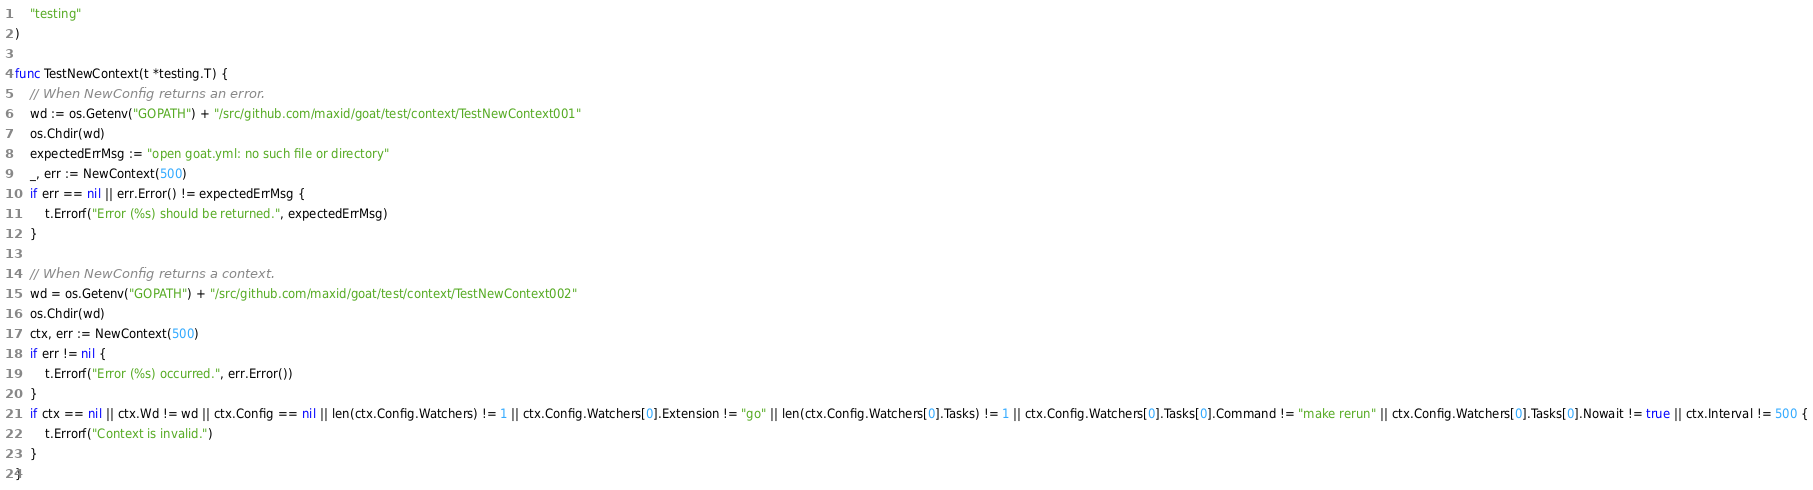<code> <loc_0><loc_0><loc_500><loc_500><_Go_>	"testing"
)

func TestNewContext(t *testing.T) {
	// When NewConfig returns an error.
	wd := os.Getenv("GOPATH") + "/src/github.com/maxid/goat/test/context/TestNewContext001"
	os.Chdir(wd)
	expectedErrMsg := "open goat.yml: no such file or directory"
	_, err := NewContext(500)
	if err == nil || err.Error() != expectedErrMsg {
		t.Errorf("Error (%s) should be returned.", expectedErrMsg)
	}

	// When NewConfig returns a context.
	wd = os.Getenv("GOPATH") + "/src/github.com/maxid/goat/test/context/TestNewContext002"
	os.Chdir(wd)
	ctx, err := NewContext(500)
	if err != nil {
		t.Errorf("Error (%s) occurred.", err.Error())
	}
	if ctx == nil || ctx.Wd != wd || ctx.Config == nil || len(ctx.Config.Watchers) != 1 || ctx.Config.Watchers[0].Extension != "go" || len(ctx.Config.Watchers[0].Tasks) != 1 || ctx.Config.Watchers[0].Tasks[0].Command != "make rerun" || ctx.Config.Watchers[0].Tasks[0].Nowait != true || ctx.Interval != 500 {
		t.Errorf("Context is invalid.")
	}
}
</code> 